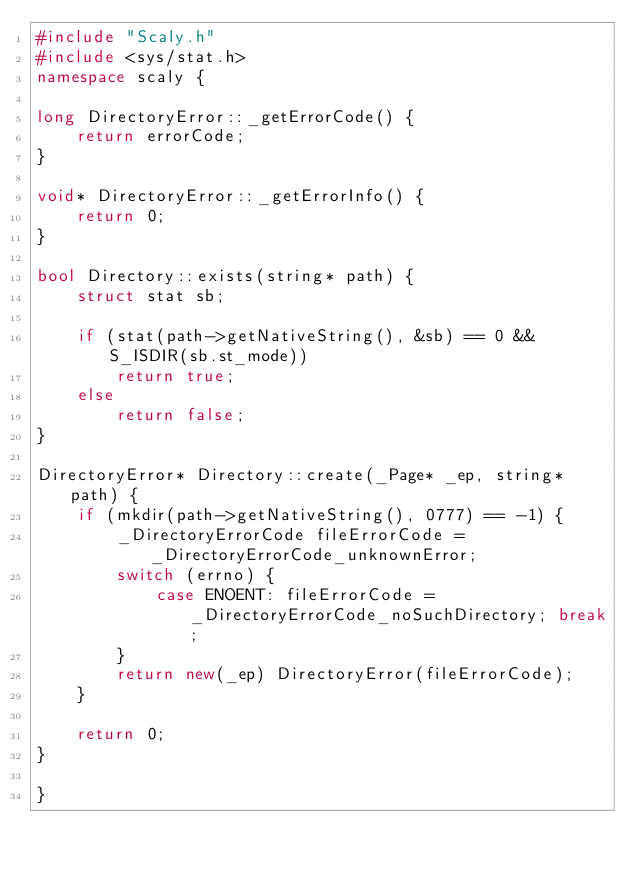<code> <loc_0><loc_0><loc_500><loc_500><_C++_>#include "Scaly.h"
#include <sys/stat.h>
namespace scaly {

long DirectoryError::_getErrorCode() {
    return errorCode;
}

void* DirectoryError::_getErrorInfo() {
    return 0;
}

bool Directory::exists(string* path) {
    struct stat sb;

    if (stat(path->getNativeString(), &sb) == 0 && S_ISDIR(sb.st_mode))
        return true;
    else
        return false;
}

DirectoryError* Directory::create(_Page* _ep, string* path) {
    if (mkdir(path->getNativeString(), 0777) == -1) {
        _DirectoryErrorCode fileErrorCode = _DirectoryErrorCode_unknownError;
        switch (errno) {
            case ENOENT: fileErrorCode = _DirectoryErrorCode_noSuchDirectory; break;
        }
        return new(_ep) DirectoryError(fileErrorCode);
    }
        
    return 0;
}

}
</code> 